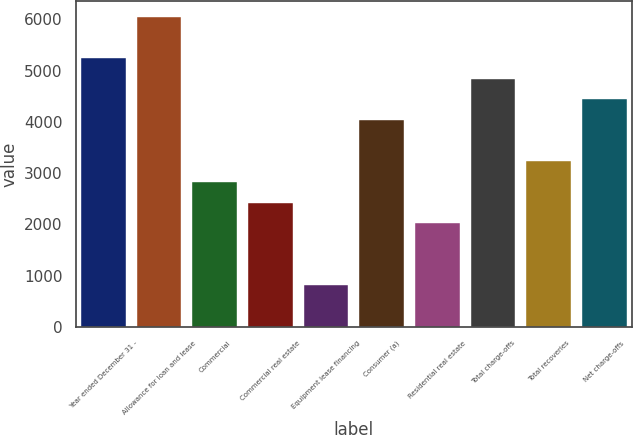Convert chart to OTSL. <chart><loc_0><loc_0><loc_500><loc_500><bar_chart><fcel>Year ended December 31 -<fcel>Allowance for loan and lease<fcel>Commercial<fcel>Commercial real estate<fcel>Equipment lease financing<fcel>Consumer (a)<fcel>Residential real estate<fcel>Total charge-offs<fcel>Total recoveries<fcel>Net charge-offs<nl><fcel>5246.3<fcel>6053.14<fcel>2825.78<fcel>2422.36<fcel>808.68<fcel>4036.04<fcel>2018.94<fcel>4842.88<fcel>3229.2<fcel>4439.46<nl></chart> 